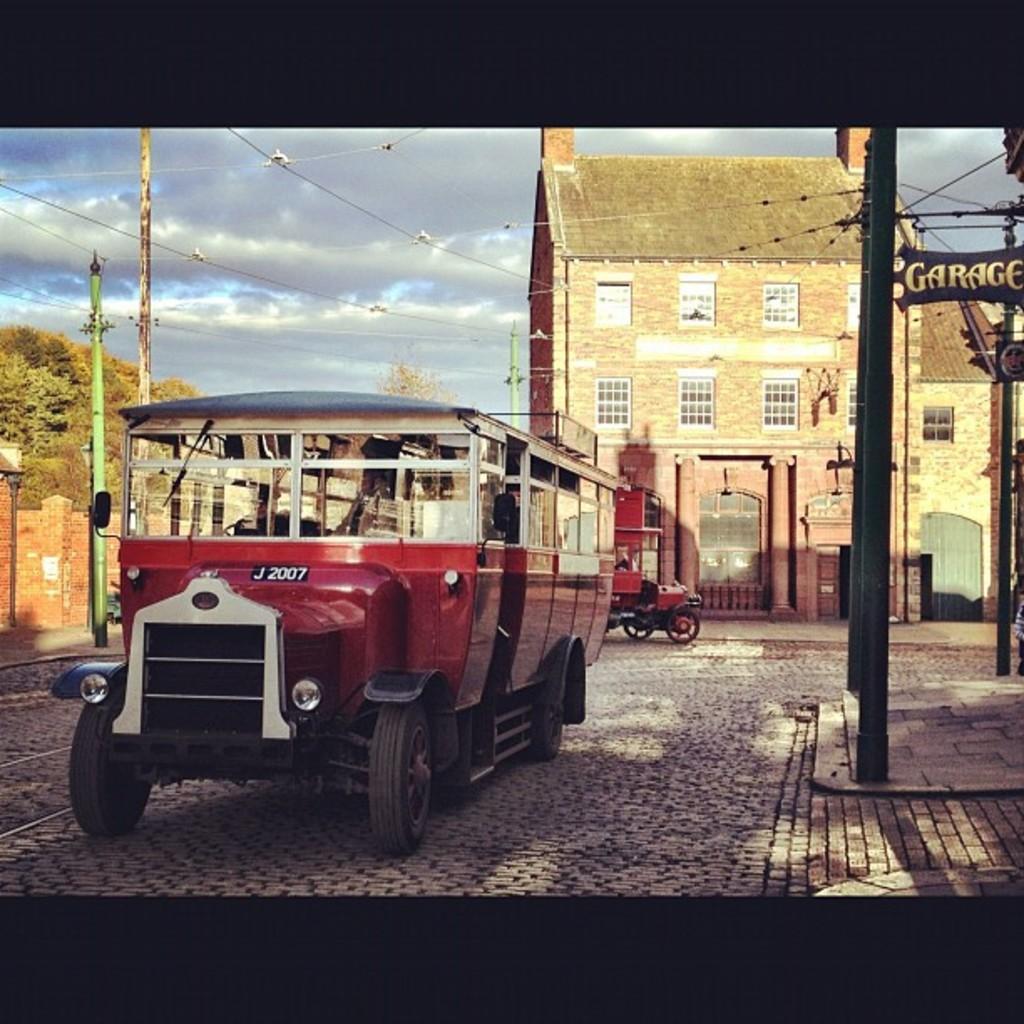How would you summarize this image in a sentence or two? In this image we can see two vehicles which are moving on road which are of red color, on right side of the image there is footpath and in the background of the image there are some wires, poles, houses, trees and cloudy sky. 